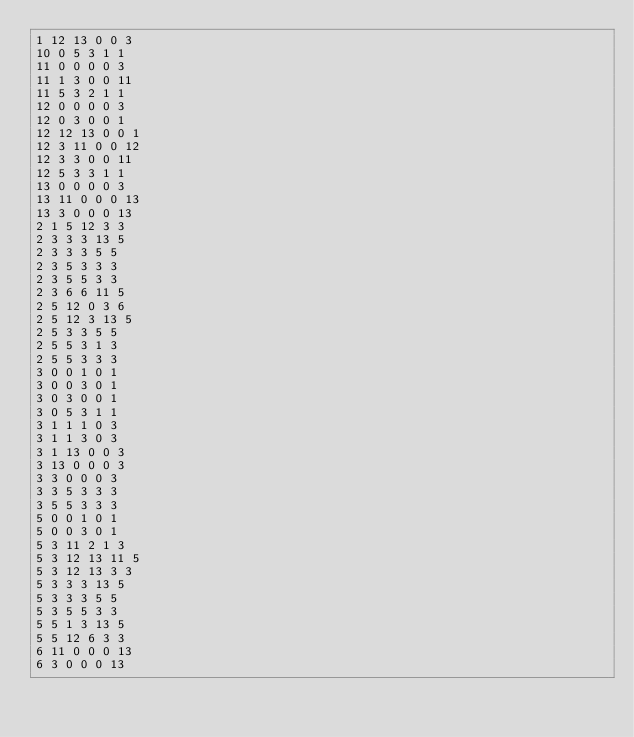Convert code to text. <code><loc_0><loc_0><loc_500><loc_500><_SQL_>1 12 13 0 0 3
10 0 5 3 1 1
11 0 0 0 0 3
11 1 3 0 0 11
11 5 3 2 1 1
12 0 0 0 0 3
12 0 3 0 0 1
12 12 13 0 0 1
12 3 11 0 0 12
12 3 3 0 0 11
12 5 3 3 1 1
13 0 0 0 0 3
13 11 0 0 0 13
13 3 0 0 0 13
2 1 5 12 3 3
2 3 3 3 13 5
2 3 3 3 5 5
2 3 5 3 3 3
2 3 5 5 3 3
2 3 6 6 11 5
2 5 12 0 3 6
2 5 12 3 13 5
2 5 3 3 5 5
2 5 5 3 1 3
2 5 5 3 3 3
3 0 0 1 0 1
3 0 0 3 0 1
3 0 3 0 0 1
3 0 5 3 1 1
3 1 1 1 0 3
3 1 1 3 0 3
3 1 13 0 0 3
3 13 0 0 0 3
3 3 0 0 0 3
3 3 5 3 3 3
3 5 5 3 3 3
5 0 0 1 0 1
5 0 0 3 0 1
5 3 11 2 1 3
5 3 12 13 11 5
5 3 12 13 3 3
5 3 3 3 13 5
5 3 3 3 5 5
5 3 5 5 3 3
5 5 1 3 13 5
5 5 12 6 3 3
6 11 0 0 0 13
6 3 0 0 0 13</code> 